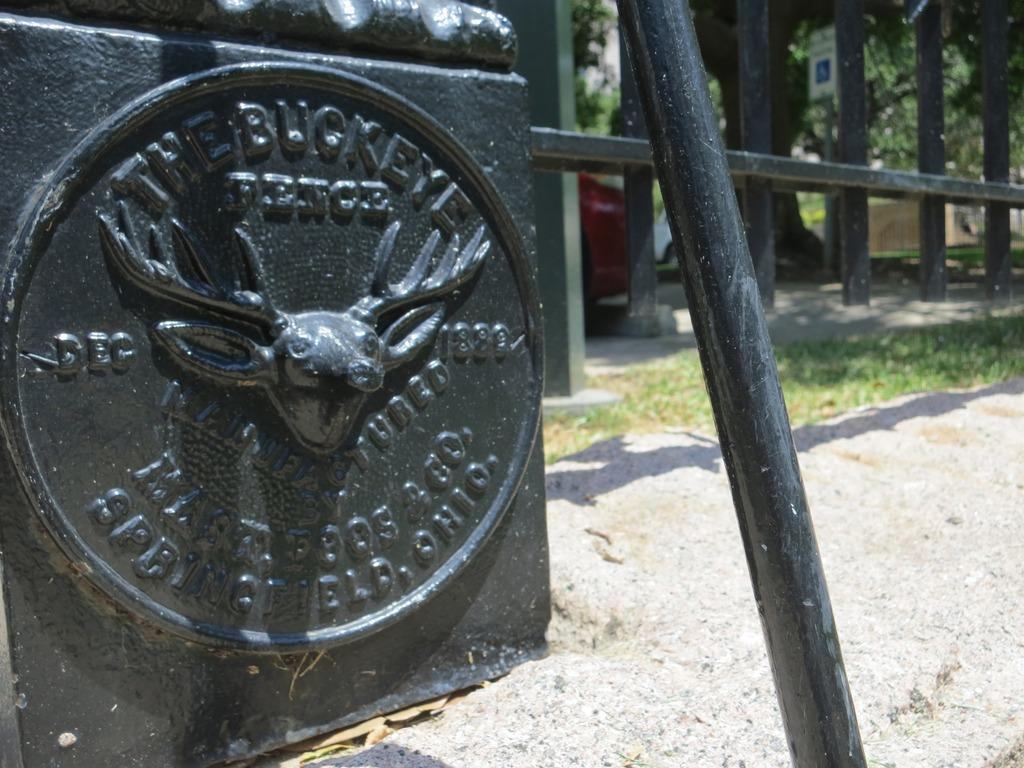What is located in the foreground of the image? In the foreground of the image, there is a board, metal rods, grass, a fence, and vehicles. What type of vegetation can be seen in the foreground of the image? Trees are visible in the foreground of the image. What structures are present in the image? There are buildings in the image. What can be inferred about the weather on the day the image was taken? The image was likely taken on a sunny day. Can you tell me how many elbows are visible in the image? There are no elbows present in the image. What type of ray is swimming in the foreground of the image? There is no ray present in the image; it features a board, metal rods, grass, a fence, vehicles, trees, and buildings. 